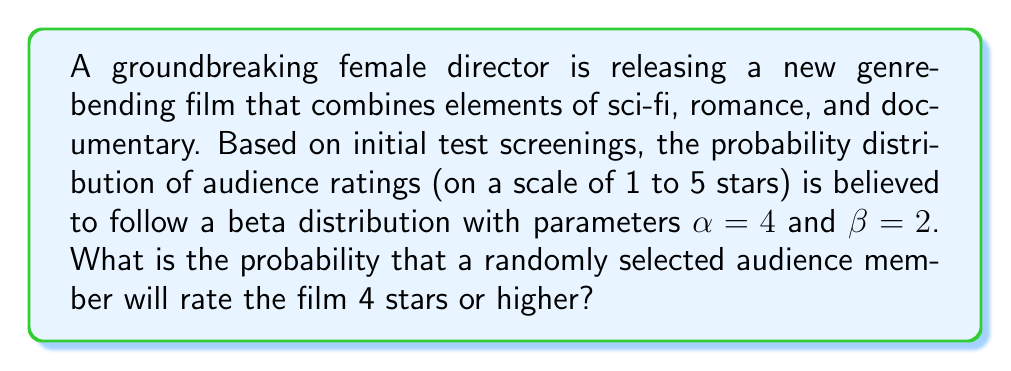Can you answer this question? To solve this problem, we need to follow these steps:

1) The beta distribution is defined on the interval [0, 1], so we need to transform our 5-star rating scale to this interval. A rating of 4 stars or higher on a 5-star scale corresponds to the interval [0.8, 1] on the [0, 1] scale.

2) The probability density function (PDF) of a beta distribution with parameters $\alpha$ and $\beta$ is given by:

   $$f(x;\alpha,\beta) = \frac{x^{\alpha-1}(1-x)^{\beta-1}}{B(\alpha,\beta)}$$

   where $B(\alpha,\beta)$ is the beta function.

3) To find the probability of a rating of 4 stars or higher, we need to integrate this PDF from 0.8 to 1:

   $$P(X \geq 0.8) = \int_{0.8}^1 \frac{x^{3}(1-x)^1}{B(4,2)} dx$$

4) This integral doesn't have a simple closed form, so we need to use the cumulative distribution function (CDF) of the beta distribution, which is the regularized incomplete beta function:

   $$P(X \leq x) = I_x(\alpha,\beta)$$

5) Therefore, our probability is:

   $$P(X \geq 0.8) = 1 - P(X < 0.8) = 1 - I_{0.8}(4,2)$$

6) Using a statistical software or calculator, we can compute:

   $$I_{0.8}(4,2) \approx 0.8192$$

7) Thus, the final probability is:

   $$P(X \geq 0.8) = 1 - 0.8192 \approx 0.1808$$
Answer: $0.1808$ or $18.08\%$ 